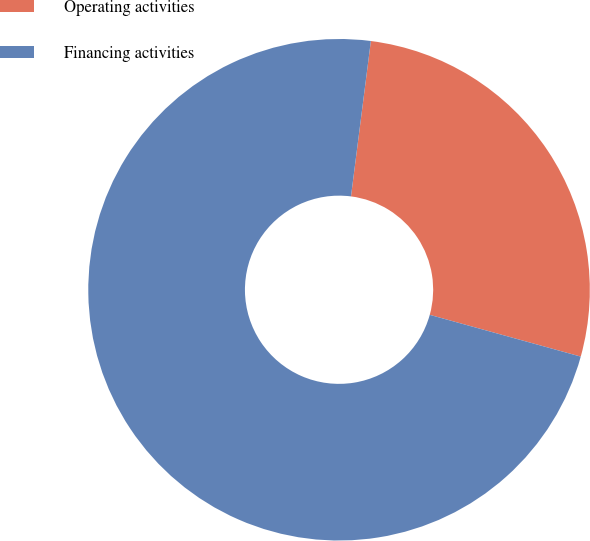<chart> <loc_0><loc_0><loc_500><loc_500><pie_chart><fcel>Operating activities<fcel>Financing activities<nl><fcel>27.27%<fcel>72.73%<nl></chart> 